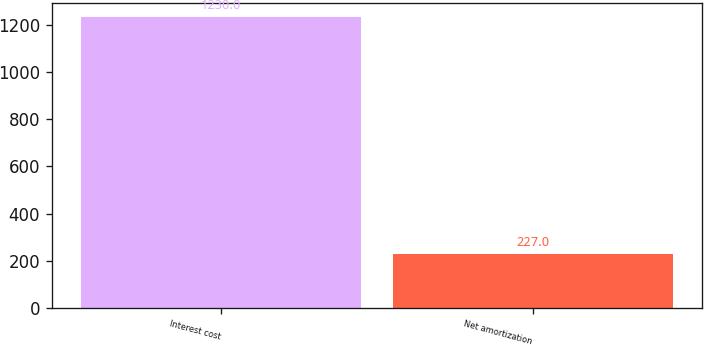Convert chart to OTSL. <chart><loc_0><loc_0><loc_500><loc_500><bar_chart><fcel>Interest cost<fcel>Net amortization<nl><fcel>1230<fcel>227<nl></chart> 